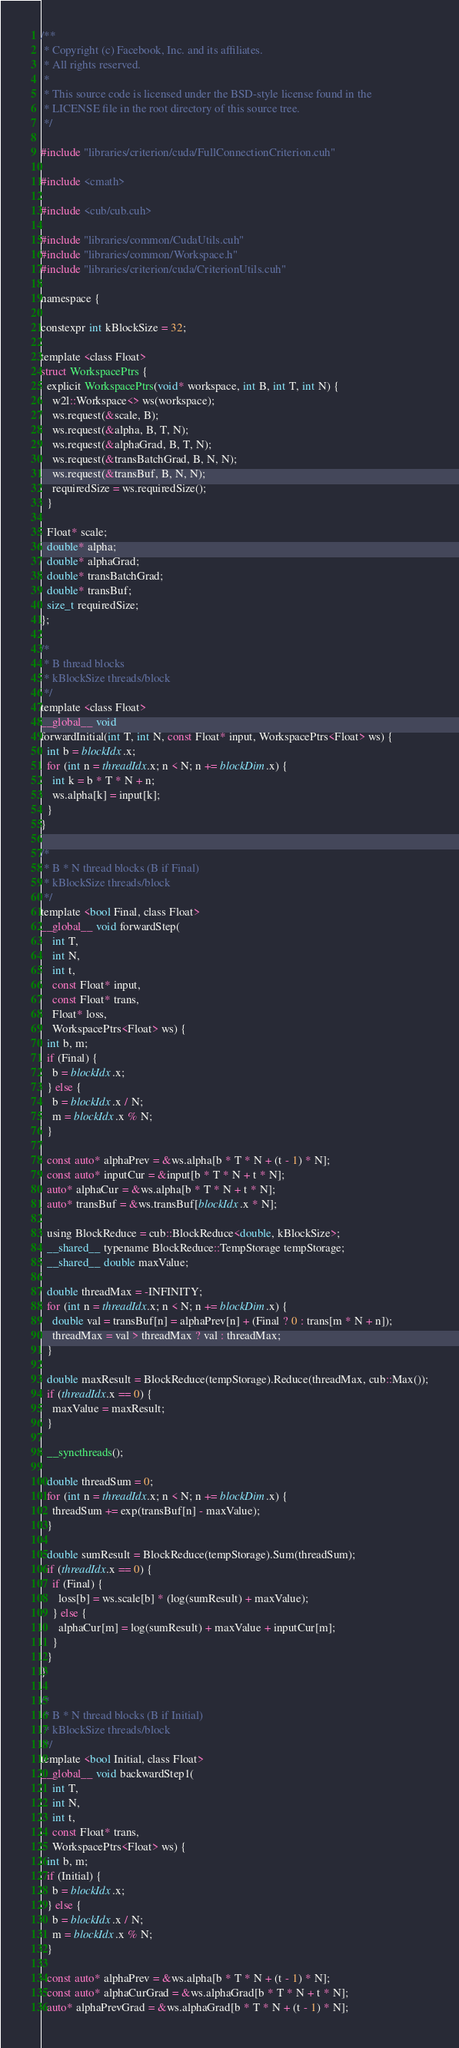<code> <loc_0><loc_0><loc_500><loc_500><_Cuda_>/**
 * Copyright (c) Facebook, Inc. and its affiliates.
 * All rights reserved.
 *
 * This source code is licensed under the BSD-style license found in the
 * LICENSE file in the root directory of this source tree.
 */

#include "libraries/criterion/cuda/FullConnectionCriterion.cuh"

#include <cmath>

#include <cub/cub.cuh>

#include "libraries/common/CudaUtils.cuh"
#include "libraries/common/Workspace.h"
#include "libraries/criterion/cuda/CriterionUtils.cuh"

namespace {

constexpr int kBlockSize = 32;

template <class Float>
struct WorkspacePtrs {
  explicit WorkspacePtrs(void* workspace, int B, int T, int N) {
    w2l::Workspace<> ws(workspace);
    ws.request(&scale, B);
    ws.request(&alpha, B, T, N);
    ws.request(&alphaGrad, B, T, N);
    ws.request(&transBatchGrad, B, N, N);
    ws.request(&transBuf, B, N, N);
    requiredSize = ws.requiredSize();
  }

  Float* scale;
  double* alpha;
  double* alphaGrad;
  double* transBatchGrad;
  double* transBuf;
  size_t requiredSize;
};

/*
 * B thread blocks
 * kBlockSize threads/block
 */
template <class Float>
__global__ void
forwardInitial(int T, int N, const Float* input, WorkspacePtrs<Float> ws) {
  int b = blockIdx.x;
  for (int n = threadIdx.x; n < N; n += blockDim.x) {
    int k = b * T * N + n;
    ws.alpha[k] = input[k];
  }
}

/*
 * B * N thread blocks (B if Final)
 * kBlockSize threads/block
 */
template <bool Final, class Float>
__global__ void forwardStep(
    int T,
    int N,
    int t,
    const Float* input,
    const Float* trans,
    Float* loss,
    WorkspacePtrs<Float> ws) {
  int b, m;
  if (Final) {
    b = blockIdx.x;
  } else {
    b = blockIdx.x / N;
    m = blockIdx.x % N;
  }

  const auto* alphaPrev = &ws.alpha[b * T * N + (t - 1) * N];
  const auto* inputCur = &input[b * T * N + t * N];
  auto* alphaCur = &ws.alpha[b * T * N + t * N];
  auto* transBuf = &ws.transBuf[blockIdx.x * N];

  using BlockReduce = cub::BlockReduce<double, kBlockSize>;
  __shared__ typename BlockReduce::TempStorage tempStorage;
  __shared__ double maxValue;

  double threadMax = -INFINITY;
  for (int n = threadIdx.x; n < N; n += blockDim.x) {
    double val = transBuf[n] = alphaPrev[n] + (Final ? 0 : trans[m * N + n]);
    threadMax = val > threadMax ? val : threadMax;
  }

  double maxResult = BlockReduce(tempStorage).Reduce(threadMax, cub::Max());
  if (threadIdx.x == 0) {
    maxValue = maxResult;
  }

  __syncthreads();

  double threadSum = 0;
  for (int n = threadIdx.x; n < N; n += blockDim.x) {
    threadSum += exp(transBuf[n] - maxValue);
  }

  double sumResult = BlockReduce(tempStorage).Sum(threadSum);
  if (threadIdx.x == 0) {
    if (Final) {
      loss[b] = ws.scale[b] * (log(sumResult) + maxValue);
    } else {
      alphaCur[m] = log(sumResult) + maxValue + inputCur[m];
    }
  }
}

/*
 * B * N thread blocks (B if Initial)
 * kBlockSize threads/block
 */
template <bool Initial, class Float>
__global__ void backwardStep1(
    int T,
    int N,
    int t,
    const Float* trans,
    WorkspacePtrs<Float> ws) {
  int b, m;
  if (Initial) {
    b = blockIdx.x;
  } else {
    b = blockIdx.x / N;
    m = blockIdx.x % N;
  }

  const auto* alphaPrev = &ws.alpha[b * T * N + (t - 1) * N];
  const auto* alphaCurGrad = &ws.alphaGrad[b * T * N + t * N];
  auto* alphaPrevGrad = &ws.alphaGrad[b * T * N + (t - 1) * N];</code> 